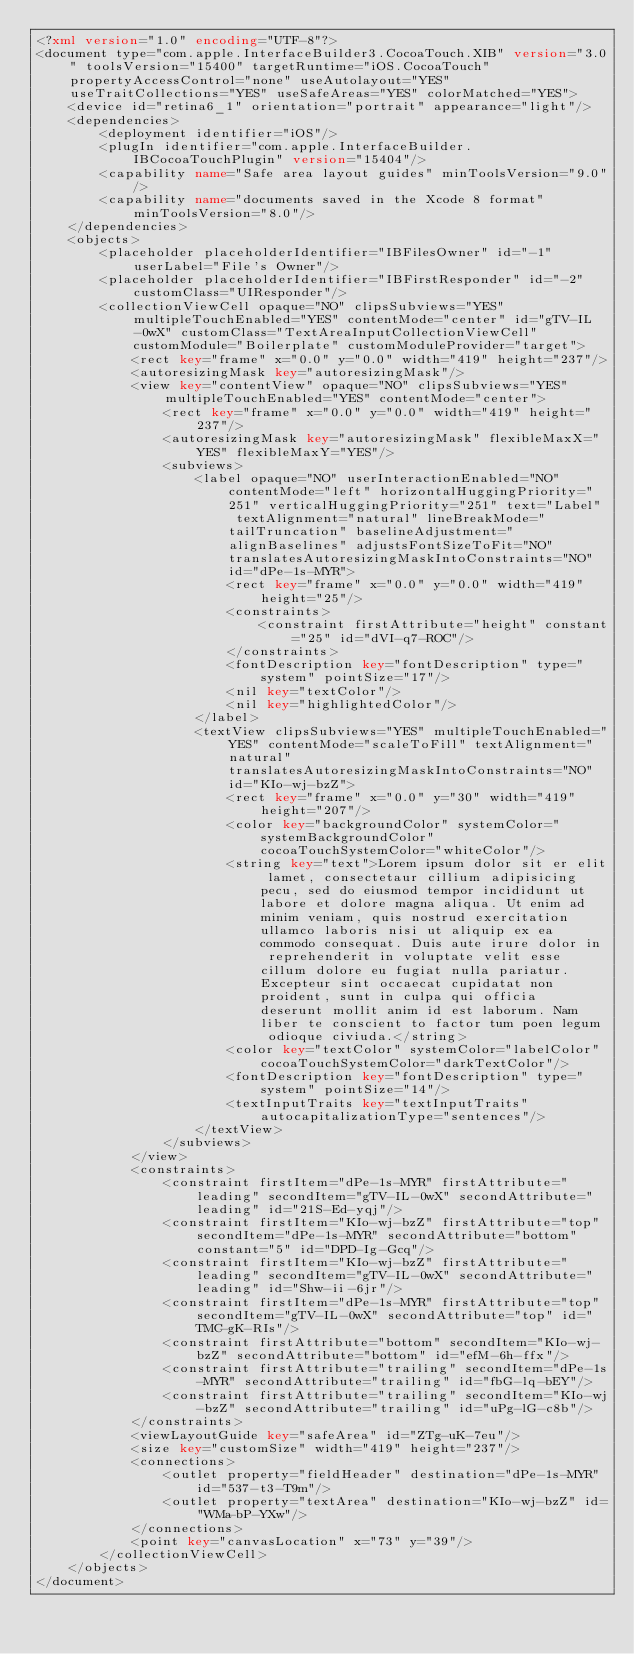Convert code to text. <code><loc_0><loc_0><loc_500><loc_500><_XML_><?xml version="1.0" encoding="UTF-8"?>
<document type="com.apple.InterfaceBuilder3.CocoaTouch.XIB" version="3.0" toolsVersion="15400" targetRuntime="iOS.CocoaTouch" propertyAccessControl="none" useAutolayout="YES" useTraitCollections="YES" useSafeAreas="YES" colorMatched="YES">
    <device id="retina6_1" orientation="portrait" appearance="light"/>
    <dependencies>
        <deployment identifier="iOS"/>
        <plugIn identifier="com.apple.InterfaceBuilder.IBCocoaTouchPlugin" version="15404"/>
        <capability name="Safe area layout guides" minToolsVersion="9.0"/>
        <capability name="documents saved in the Xcode 8 format" minToolsVersion="8.0"/>
    </dependencies>
    <objects>
        <placeholder placeholderIdentifier="IBFilesOwner" id="-1" userLabel="File's Owner"/>
        <placeholder placeholderIdentifier="IBFirstResponder" id="-2" customClass="UIResponder"/>
        <collectionViewCell opaque="NO" clipsSubviews="YES" multipleTouchEnabled="YES" contentMode="center" id="gTV-IL-0wX" customClass="TextAreaInputCollectionViewCell" customModule="Boilerplate" customModuleProvider="target">
            <rect key="frame" x="0.0" y="0.0" width="419" height="237"/>
            <autoresizingMask key="autoresizingMask"/>
            <view key="contentView" opaque="NO" clipsSubviews="YES" multipleTouchEnabled="YES" contentMode="center">
                <rect key="frame" x="0.0" y="0.0" width="419" height="237"/>
                <autoresizingMask key="autoresizingMask" flexibleMaxX="YES" flexibleMaxY="YES"/>
                <subviews>
                    <label opaque="NO" userInteractionEnabled="NO" contentMode="left" horizontalHuggingPriority="251" verticalHuggingPriority="251" text="Label" textAlignment="natural" lineBreakMode="tailTruncation" baselineAdjustment="alignBaselines" adjustsFontSizeToFit="NO" translatesAutoresizingMaskIntoConstraints="NO" id="dPe-1s-MYR">
                        <rect key="frame" x="0.0" y="0.0" width="419" height="25"/>
                        <constraints>
                            <constraint firstAttribute="height" constant="25" id="dVI-q7-ROC"/>
                        </constraints>
                        <fontDescription key="fontDescription" type="system" pointSize="17"/>
                        <nil key="textColor"/>
                        <nil key="highlightedColor"/>
                    </label>
                    <textView clipsSubviews="YES" multipleTouchEnabled="YES" contentMode="scaleToFill" textAlignment="natural" translatesAutoresizingMaskIntoConstraints="NO" id="KIo-wj-bzZ">
                        <rect key="frame" x="0.0" y="30" width="419" height="207"/>
                        <color key="backgroundColor" systemColor="systemBackgroundColor" cocoaTouchSystemColor="whiteColor"/>
                        <string key="text">Lorem ipsum dolor sit er elit lamet, consectetaur cillium adipisicing pecu, sed do eiusmod tempor incididunt ut labore et dolore magna aliqua. Ut enim ad minim veniam, quis nostrud exercitation ullamco laboris nisi ut aliquip ex ea commodo consequat. Duis aute irure dolor in reprehenderit in voluptate velit esse cillum dolore eu fugiat nulla pariatur. Excepteur sint occaecat cupidatat non proident, sunt in culpa qui officia deserunt mollit anim id est laborum. Nam liber te conscient to factor tum poen legum odioque civiuda.</string>
                        <color key="textColor" systemColor="labelColor" cocoaTouchSystemColor="darkTextColor"/>
                        <fontDescription key="fontDescription" type="system" pointSize="14"/>
                        <textInputTraits key="textInputTraits" autocapitalizationType="sentences"/>
                    </textView>
                </subviews>
            </view>
            <constraints>
                <constraint firstItem="dPe-1s-MYR" firstAttribute="leading" secondItem="gTV-IL-0wX" secondAttribute="leading" id="21S-Ed-yqj"/>
                <constraint firstItem="KIo-wj-bzZ" firstAttribute="top" secondItem="dPe-1s-MYR" secondAttribute="bottom" constant="5" id="DPD-Ig-Gcq"/>
                <constraint firstItem="KIo-wj-bzZ" firstAttribute="leading" secondItem="gTV-IL-0wX" secondAttribute="leading" id="Shw-ii-6jr"/>
                <constraint firstItem="dPe-1s-MYR" firstAttribute="top" secondItem="gTV-IL-0wX" secondAttribute="top" id="TMC-gK-RIs"/>
                <constraint firstAttribute="bottom" secondItem="KIo-wj-bzZ" secondAttribute="bottom" id="efM-6h-ffx"/>
                <constraint firstAttribute="trailing" secondItem="dPe-1s-MYR" secondAttribute="trailing" id="fbG-lq-bEY"/>
                <constraint firstAttribute="trailing" secondItem="KIo-wj-bzZ" secondAttribute="trailing" id="uPg-lG-c8b"/>
            </constraints>
            <viewLayoutGuide key="safeArea" id="ZTg-uK-7eu"/>
            <size key="customSize" width="419" height="237"/>
            <connections>
                <outlet property="fieldHeader" destination="dPe-1s-MYR" id="537-t3-T9m"/>
                <outlet property="textArea" destination="KIo-wj-bzZ" id="WMa-bP-YXw"/>
            </connections>
            <point key="canvasLocation" x="73" y="39"/>
        </collectionViewCell>
    </objects>
</document>
</code> 